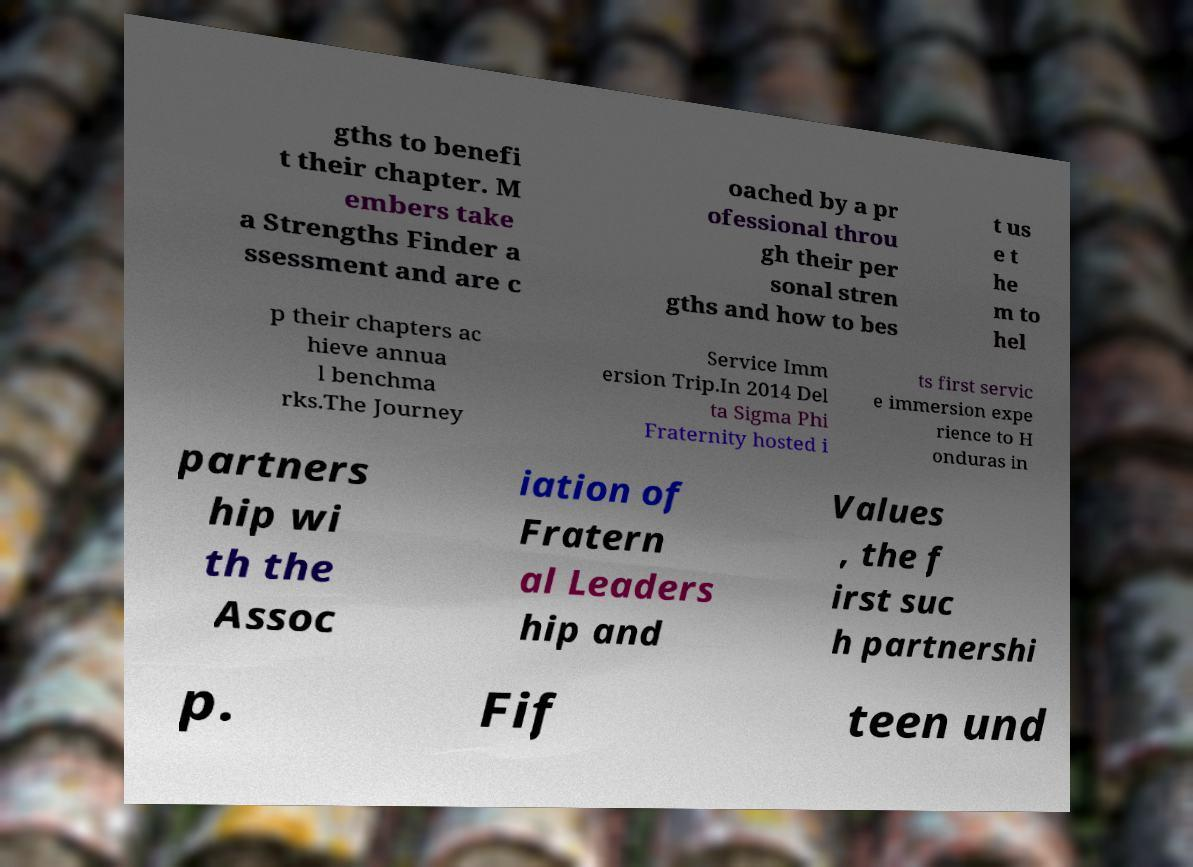I need the written content from this picture converted into text. Can you do that? gths to benefi t their chapter. M embers take a Strengths Finder a ssessment and are c oached by a pr ofessional throu gh their per sonal stren gths and how to bes t us e t he m to hel p their chapters ac hieve annua l benchma rks.The Journey Service Imm ersion Trip.In 2014 Del ta Sigma Phi Fraternity hosted i ts first servic e immersion expe rience to H onduras in partners hip wi th the Assoc iation of Fratern al Leaders hip and Values , the f irst suc h partnershi p. Fif teen und 